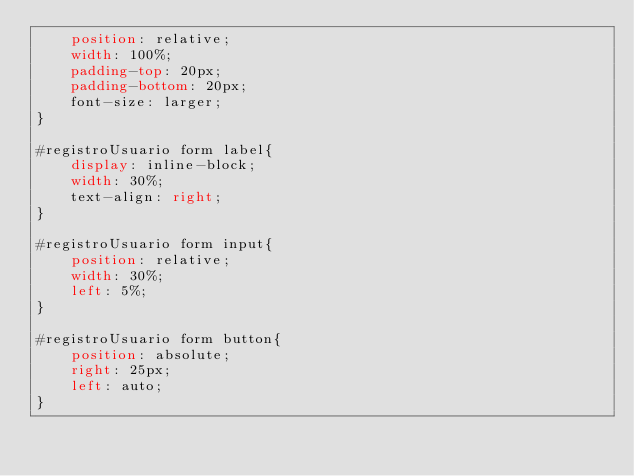Convert code to text. <code><loc_0><loc_0><loc_500><loc_500><_CSS_>    position: relative;
    width: 100%;
    padding-top: 20px;
    padding-bottom: 20px;
    font-size: larger;
}

#registroUsuario form label{
    display: inline-block;
    width: 30%;
    text-align: right;
}

#registroUsuario form input{
    position: relative;
    width: 30%;
    left: 5%;
}

#registroUsuario form button{
    position: absolute;
    right: 25px;
    left: auto;
}</code> 